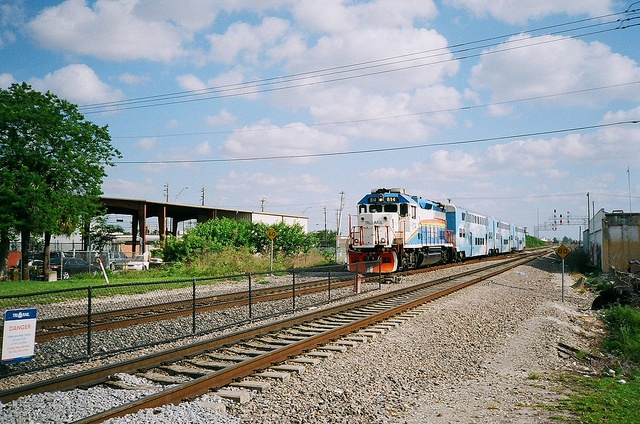Describe the objects in this image and their specific colors. I can see train in gray, lightgray, black, darkgray, and lightblue tones, car in gray, darkgray, and black tones, car in gray, black, purple, and darkblue tones, car in gray, lightgray, and darkgray tones, and car in gray, black, darkgreen, and lightgray tones in this image. 